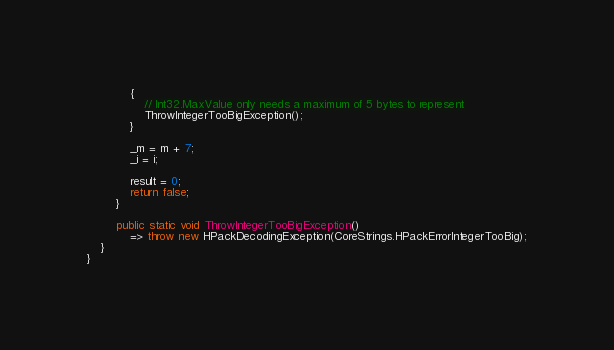Convert code to text. <code><loc_0><loc_0><loc_500><loc_500><_C#_>            {
                // Int32.MaxValue only needs a maximum of 5 bytes to represent
                ThrowIntegerTooBigException();
            }

            _m = m + 7;
            _i = i;

            result = 0;
            return false;
        }

        public static void ThrowIntegerTooBigException()
            => throw new HPackDecodingException(CoreStrings.HPackErrorIntegerTooBig);
    }
}
</code> 